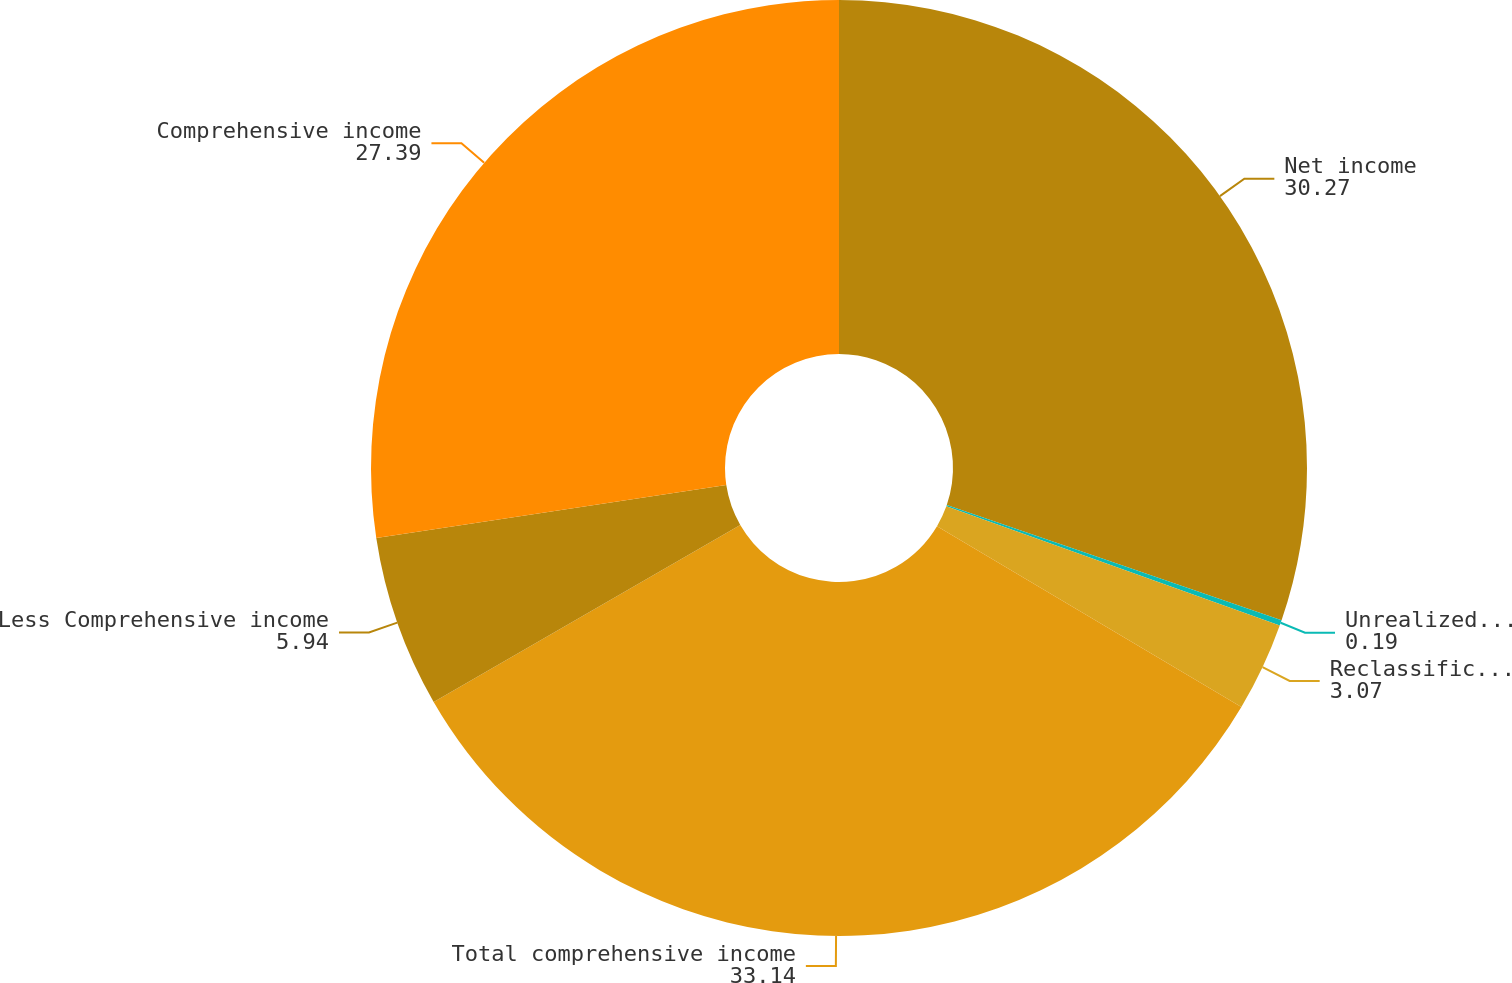Convert chart to OTSL. <chart><loc_0><loc_0><loc_500><loc_500><pie_chart><fcel>Net income<fcel>Unrealized (loss) gain from<fcel>Reclassification adjustment<fcel>Total comprehensive income<fcel>Less Comprehensive income<fcel>Comprehensive income<nl><fcel>30.27%<fcel>0.19%<fcel>3.07%<fcel>33.14%<fcel>5.94%<fcel>27.39%<nl></chart> 